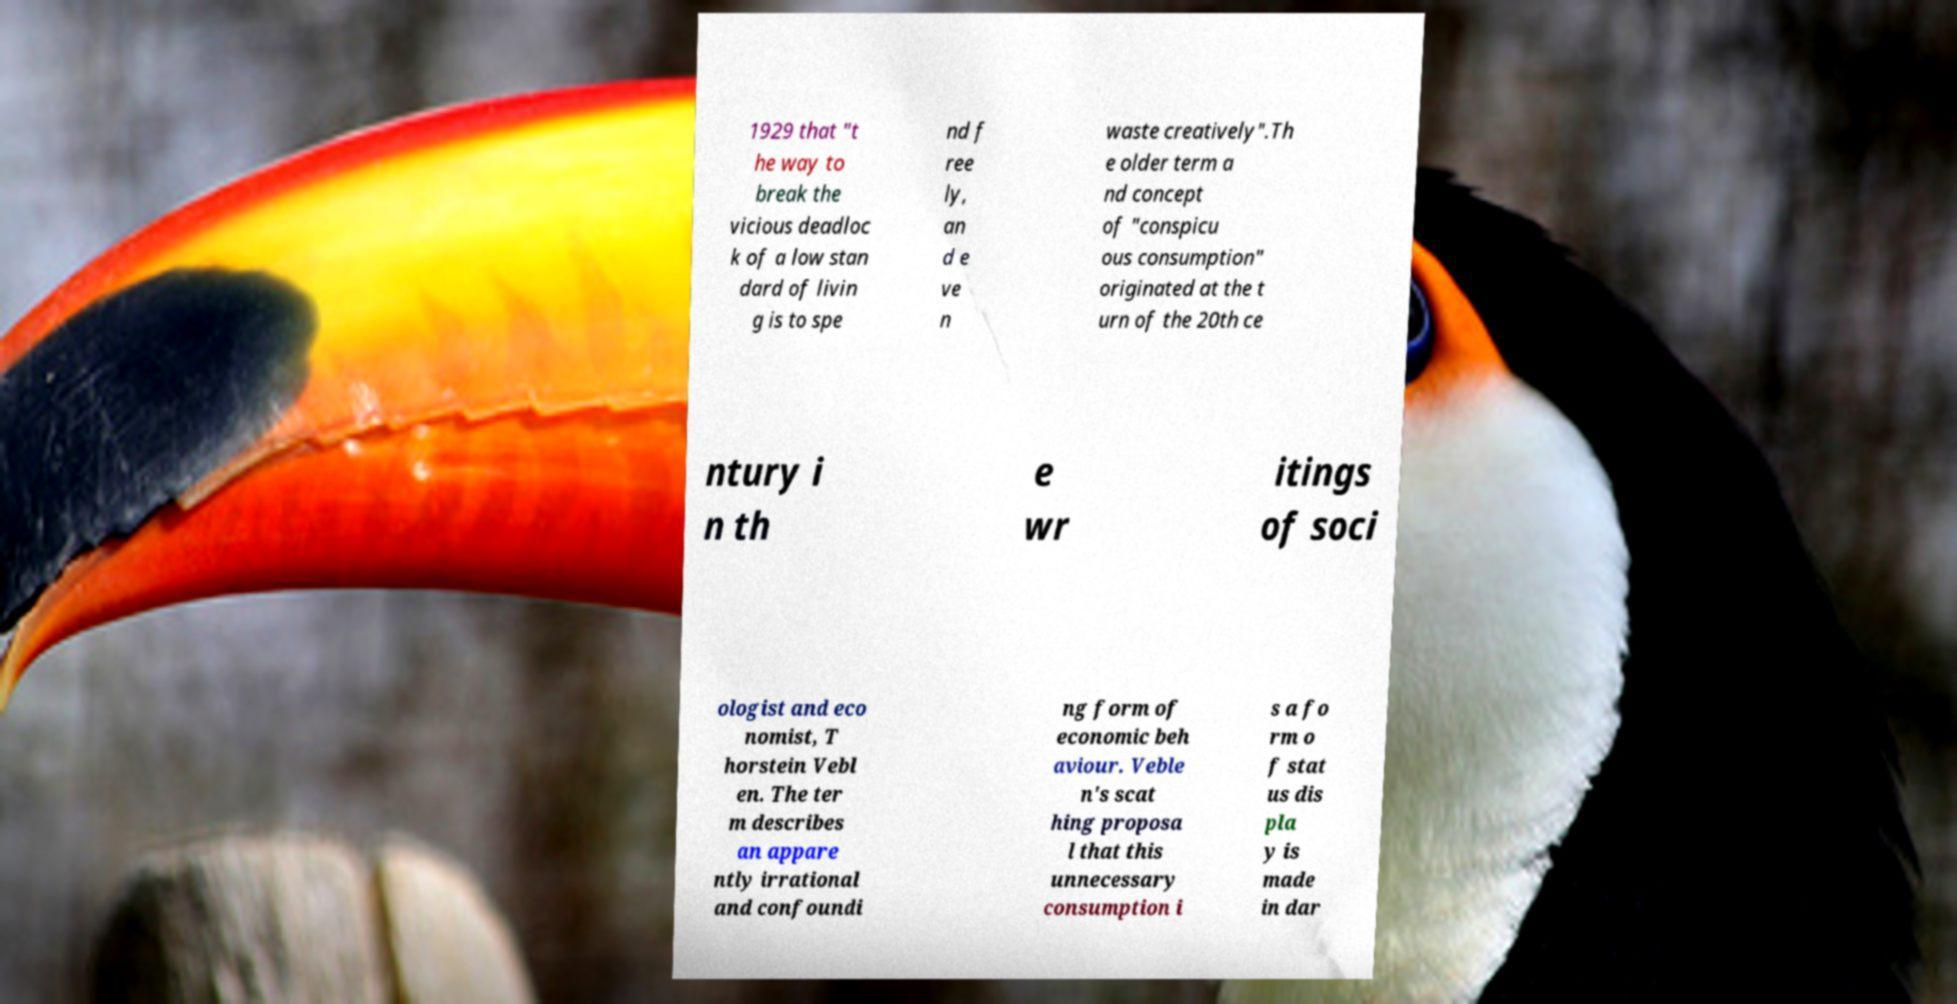Could you extract and type out the text from this image? 1929 that "t he way to break the vicious deadloc k of a low stan dard of livin g is to spe nd f ree ly, an d e ve n waste creatively".Th e older term a nd concept of "conspicu ous consumption" originated at the t urn of the 20th ce ntury i n th e wr itings of soci ologist and eco nomist, T horstein Vebl en. The ter m describes an appare ntly irrational and confoundi ng form of economic beh aviour. Veble n's scat hing proposa l that this unnecessary consumption i s a fo rm o f stat us dis pla y is made in dar 